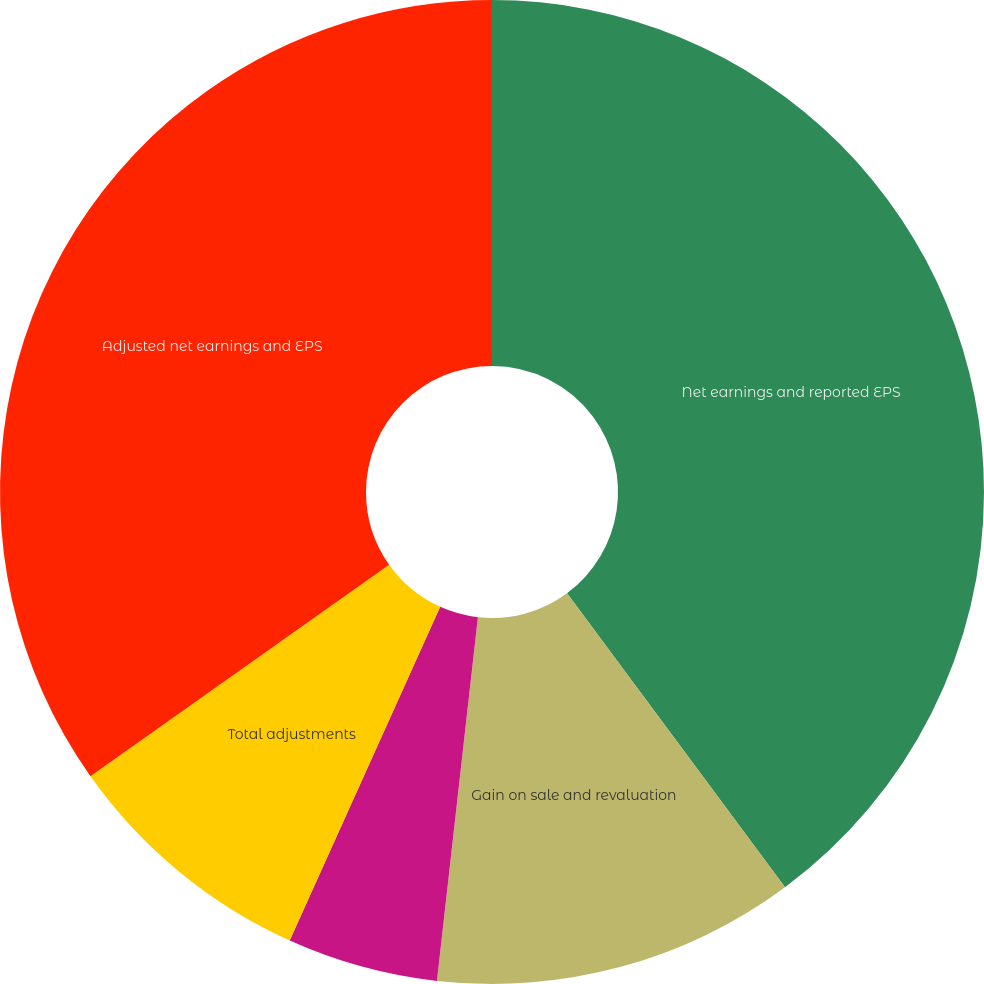<chart> <loc_0><loc_0><loc_500><loc_500><pie_chart><fcel>Net earnings and reported EPS<fcel>Gain on sale and revaluation<fcel>Asset impairment restructuring<fcel>Total adjustments<fcel>Adjusted net earnings and EPS<nl><fcel>39.85%<fcel>11.94%<fcel>4.96%<fcel>8.45%<fcel>34.81%<nl></chart> 